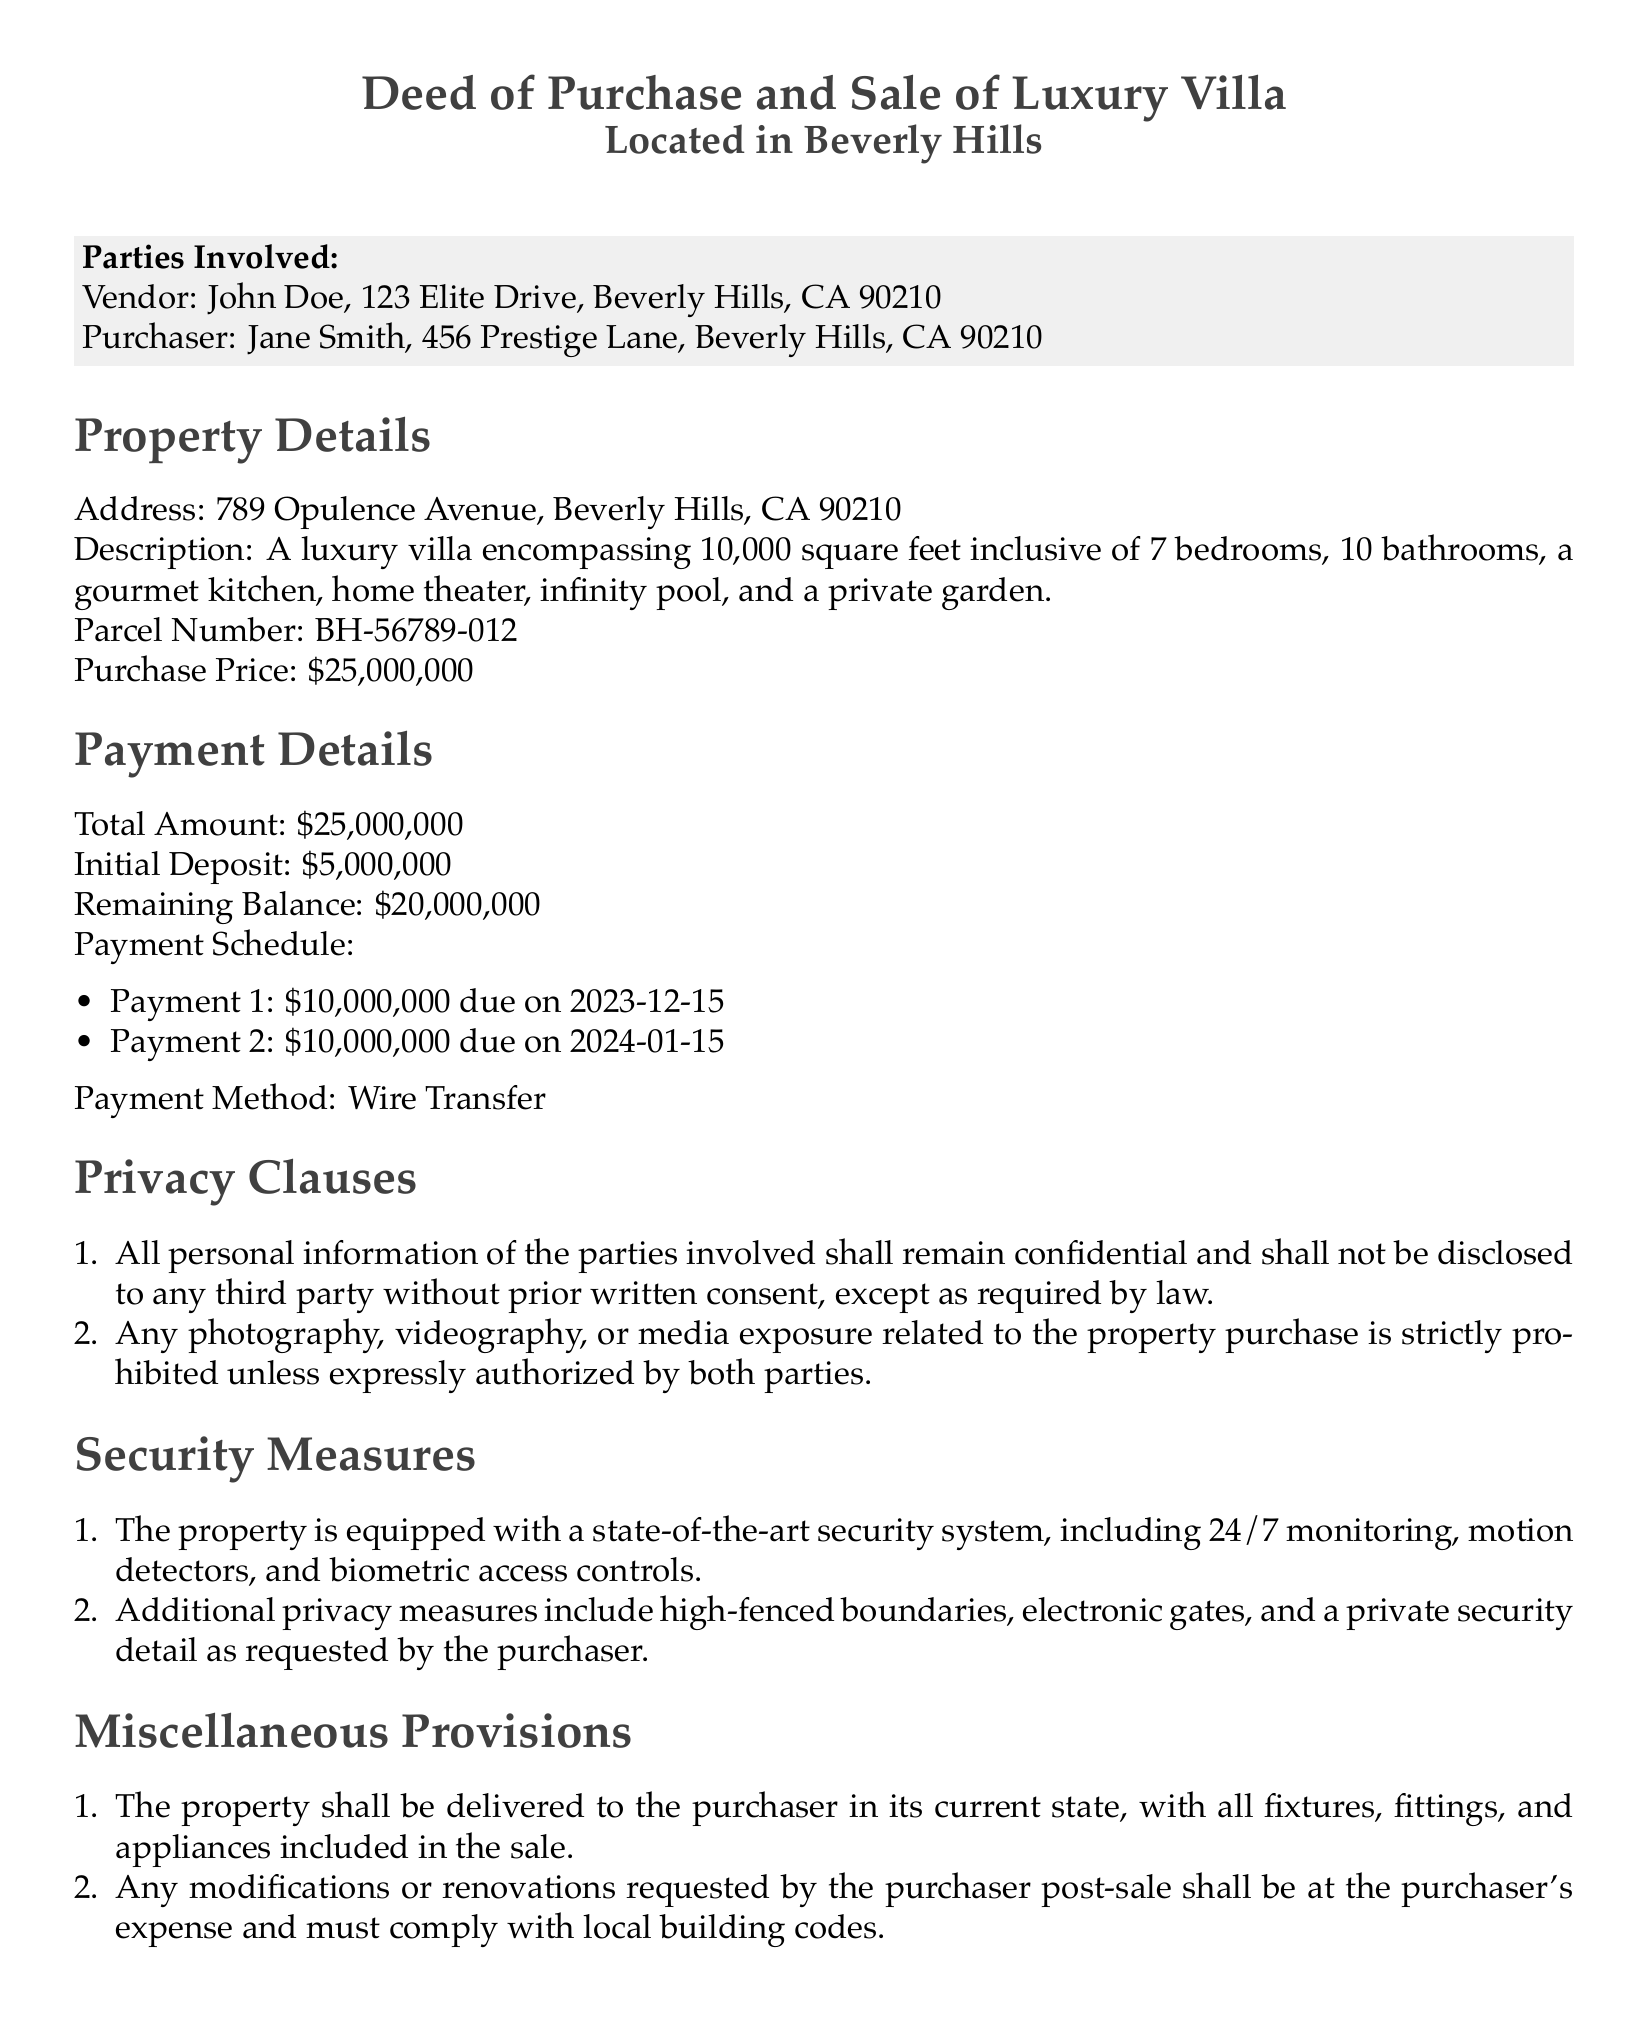What is the purchase price of the villa? The purchase price is stated in the document as the total for the property, which is twenty-five million dollars.
Answer: twenty-five million dollars Who is the vendor? The document specifies the name of the vendor involved in the transaction, which is John Doe.
Answer: John Doe What security measure is included for the property? The document lists specific features regarding security measures, indicating a state-of-the-art security system is in place.
Answer: state-of-the-art security system What is the total deposit amount? The total deposit amount is explicitly mentioned in the payment details section of the document.
Answer: five million dollars When is the second payment due? The payment schedule outlines specific due dates for payments, including the second payment due date of January 15, 2024.
Answer: January 15, 2024 What clause prevents media exposure? One of the privacy clauses specifically prohibits media exposure unless authorized by both parties.
Answer: strictly prohibited What is the address of the luxury villa? The document provides the full address of the property being sold, located on Opulence Avenue.
Answer: 789 Opulence Avenue, Beverly Hills, CA 90210 What happens to modifications requested by the purchaser? The miscellaneous provisions clarify the responsibility for any modifications or renovations made post-sale.
Answer: at the purchaser's expense 